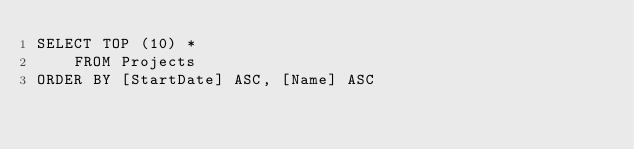Convert code to text. <code><loc_0><loc_0><loc_500><loc_500><_SQL_>SELECT TOP (10) *
    FROM Projects
ORDER BY [StartDate] ASC, [Name] ASC</code> 